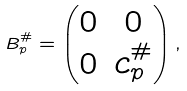Convert formula to latex. <formula><loc_0><loc_0><loc_500><loc_500>B _ { p } ^ { \# } = \begin{pmatrix} 0 & 0 \\ 0 & c _ { p } ^ { \# } \end{pmatrix} ,</formula> 